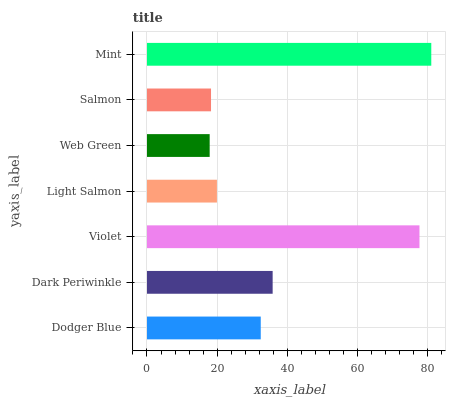Is Web Green the minimum?
Answer yes or no. Yes. Is Mint the maximum?
Answer yes or no. Yes. Is Dark Periwinkle the minimum?
Answer yes or no. No. Is Dark Periwinkle the maximum?
Answer yes or no. No. Is Dark Periwinkle greater than Dodger Blue?
Answer yes or no. Yes. Is Dodger Blue less than Dark Periwinkle?
Answer yes or no. Yes. Is Dodger Blue greater than Dark Periwinkle?
Answer yes or no. No. Is Dark Periwinkle less than Dodger Blue?
Answer yes or no. No. Is Dodger Blue the high median?
Answer yes or no. Yes. Is Dodger Blue the low median?
Answer yes or no. Yes. Is Mint the high median?
Answer yes or no. No. Is Violet the low median?
Answer yes or no. No. 